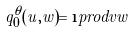<formula> <loc_0><loc_0><loc_500><loc_500>q ^ { \theta } _ { 0 } ( u , w ) = \i p r o d v w</formula> 